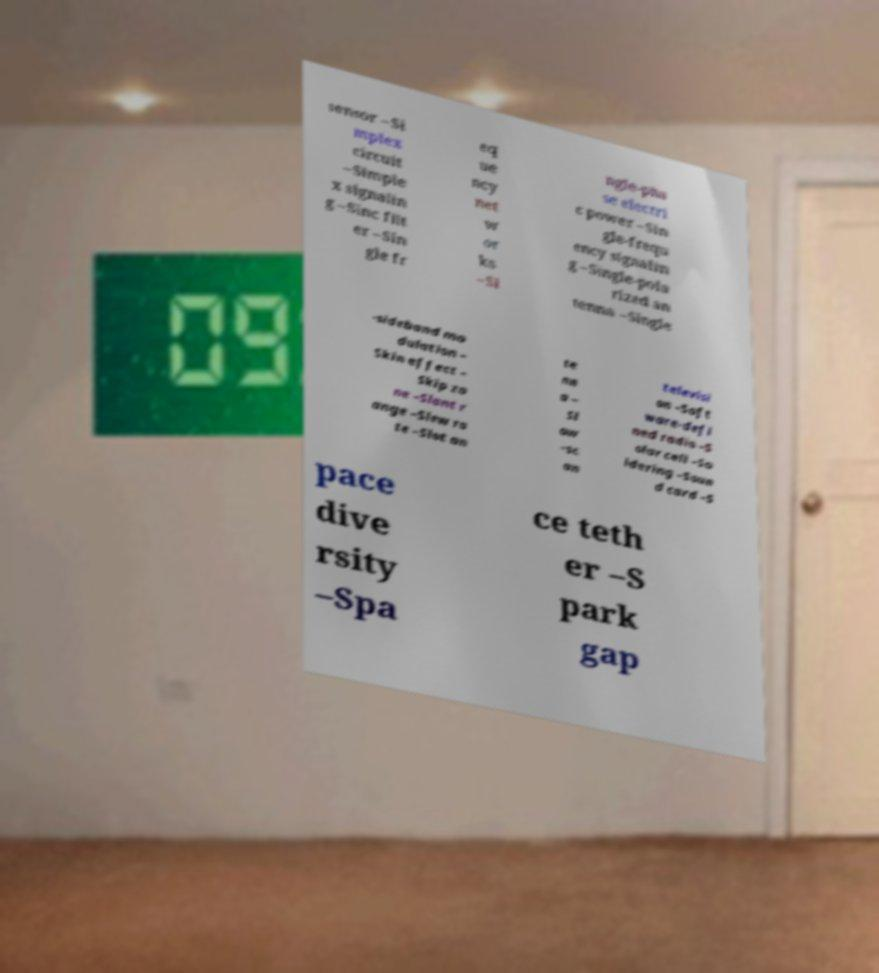Could you assist in decoding the text presented in this image and type it out clearly? sensor –Si mplex circuit –Simple x signalin g –Sinc filt er –Sin gle fr eq ue ncy net w or ks –Si ngle-pha se electri c power –Sin gle-frequ ency signalin g –Single-pola rized an tenna –Single -sideband mo dulation – Skin effect – Skip zo ne –Slant r ange –Slew ra te –Slot an te nn a – Sl ow -sc an televisi on –Soft ware-defi ned radio –S olar cell –So ldering –Soun d card –S pace dive rsity –Spa ce teth er –S park gap 